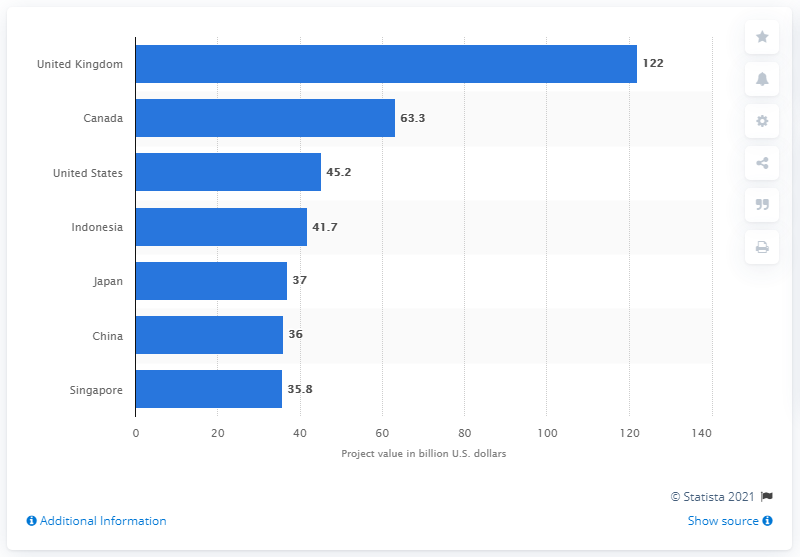Identify some key points in this picture. In the United States, the value of infrastructure projects in 2016-2017 was approximately 45.2 billion dollars. 